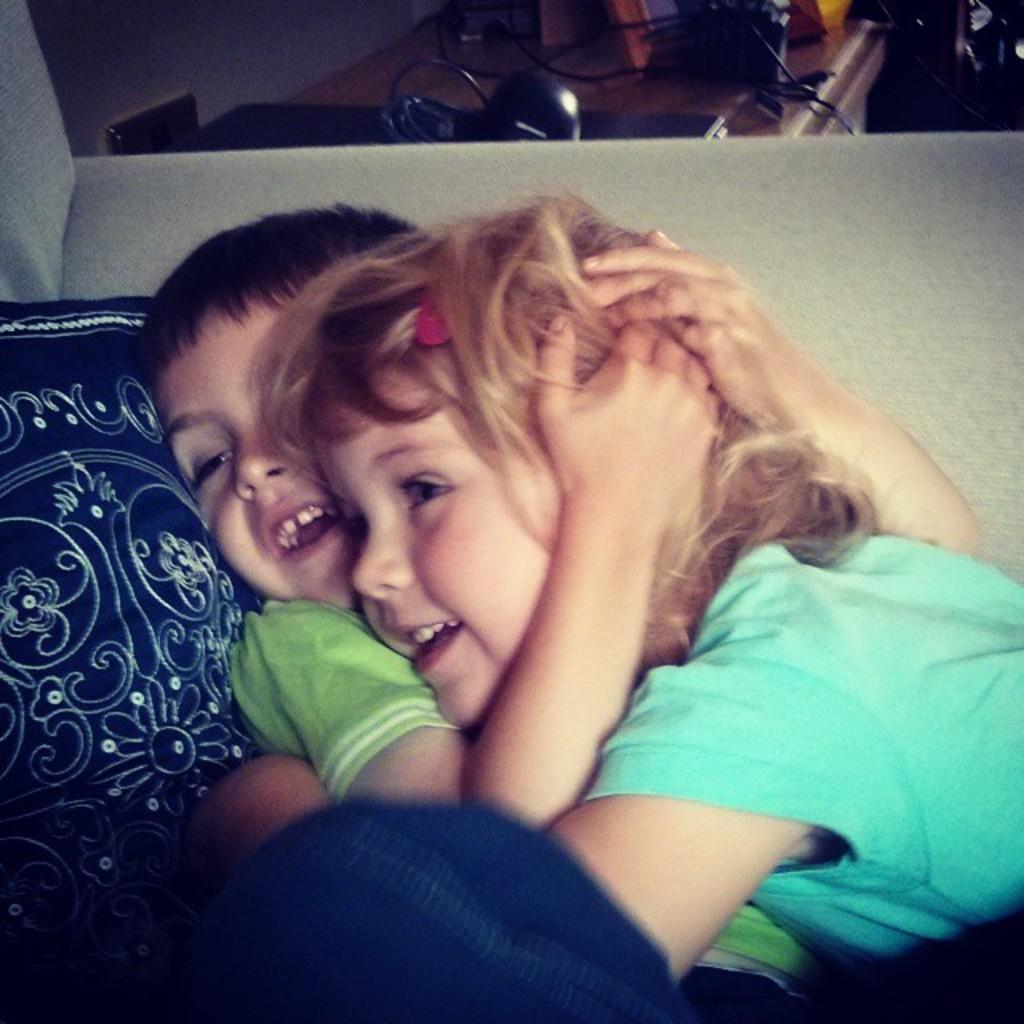How would you summarize this image in a sentence or two? In this image I can see two people are smiling and wearing different color dresses. Back I can see few objects on the table and navy blue color cloth. 